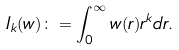Convert formula to latex. <formula><loc_0><loc_0><loc_500><loc_500>I _ { k } ( w ) \colon = \int _ { 0 } ^ { \infty } w ( r ) r ^ { k } d r .</formula> 